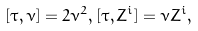Convert formula to latex. <formula><loc_0><loc_0><loc_500><loc_500>[ \tau , \nu ] = 2 \nu ^ { 2 } , [ \tau , Z ^ { i } ] = \nu Z ^ { i } ,</formula> 